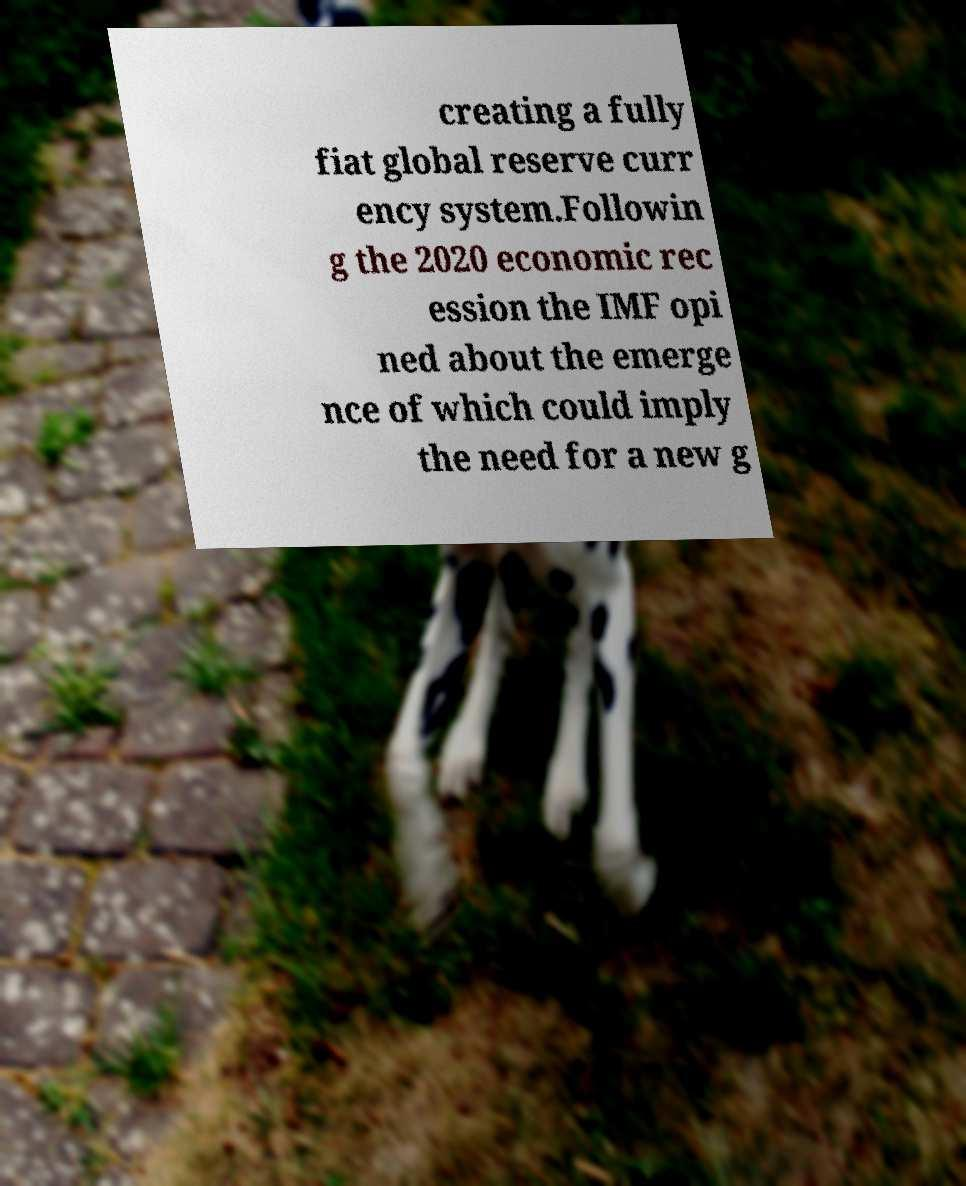Can you read and provide the text displayed in the image?This photo seems to have some interesting text. Can you extract and type it out for me? creating a fully fiat global reserve curr ency system.Followin g the 2020 economic rec ession the IMF opi ned about the emerge nce of which could imply the need for a new g 